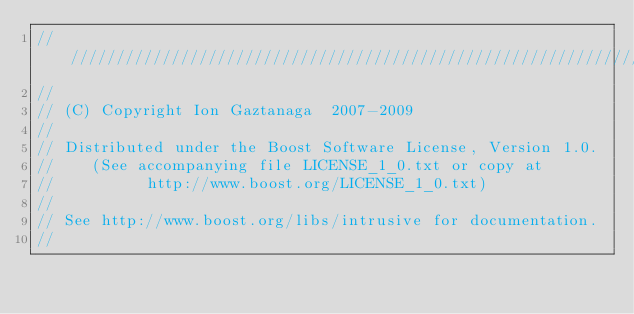<code> <loc_0><loc_0><loc_500><loc_500><_C++_>/////////////////////////////////////////////////////////////////////////////
//
// (C) Copyright Ion Gaztanaga  2007-2009
//
// Distributed under the Boost Software License, Version 1.0.
//    (See accompanying file LICENSE_1_0.txt or copy at
//          http://www.boost.org/LICENSE_1_0.txt)
//
// See http://www.boost.org/libs/intrusive for documentation.
//</code> 